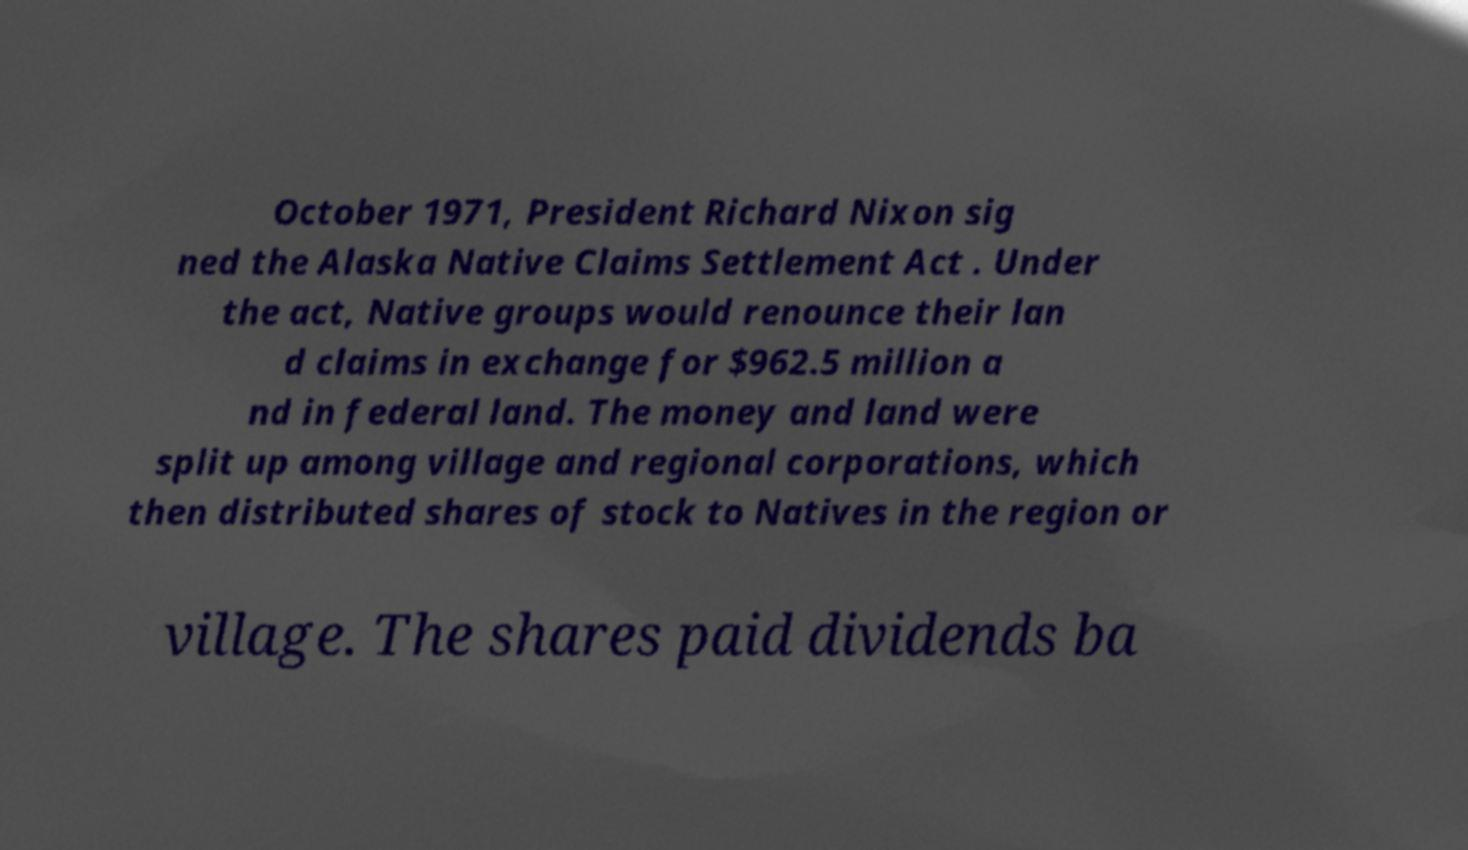Could you extract and type out the text from this image? October 1971, President Richard Nixon sig ned the Alaska Native Claims Settlement Act . Under the act, Native groups would renounce their lan d claims in exchange for $962.5 million a nd in federal land. The money and land were split up among village and regional corporations, which then distributed shares of stock to Natives in the region or village. The shares paid dividends ba 